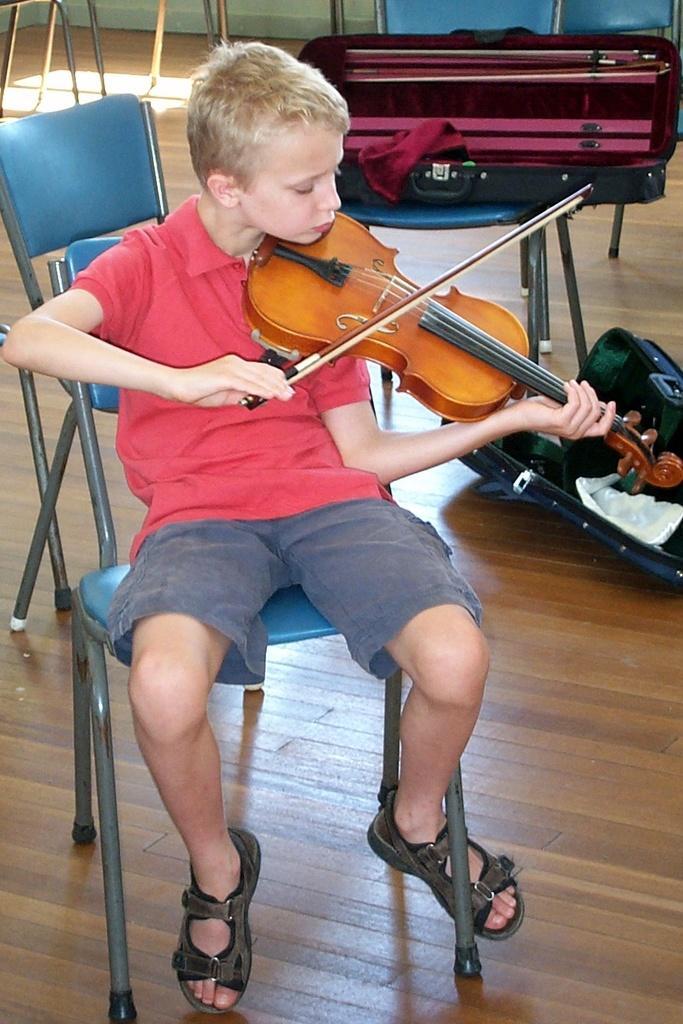In one or two sentences, can you explain what this image depicts? The image is inside the room. In the image there is a boy sitting on chair holding his violin and playing it. On right side there is another chair, on chair there some suitcase. 